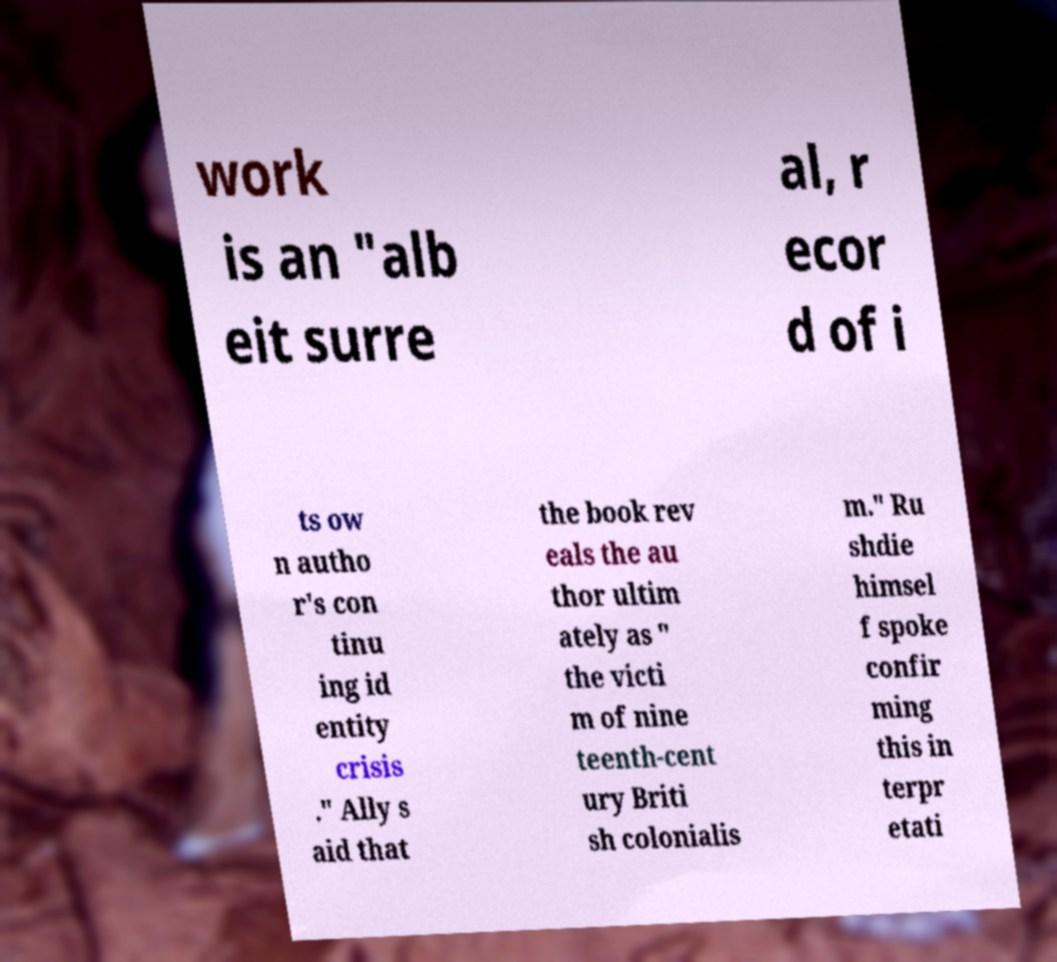Can you read and provide the text displayed in the image?This photo seems to have some interesting text. Can you extract and type it out for me? work is an "alb eit surre al, r ecor d of i ts ow n autho r's con tinu ing id entity crisis ." Ally s aid that the book rev eals the au thor ultim ately as " the victi m of nine teenth-cent ury Briti sh colonialis m." Ru shdie himsel f spoke confir ming this in terpr etati 